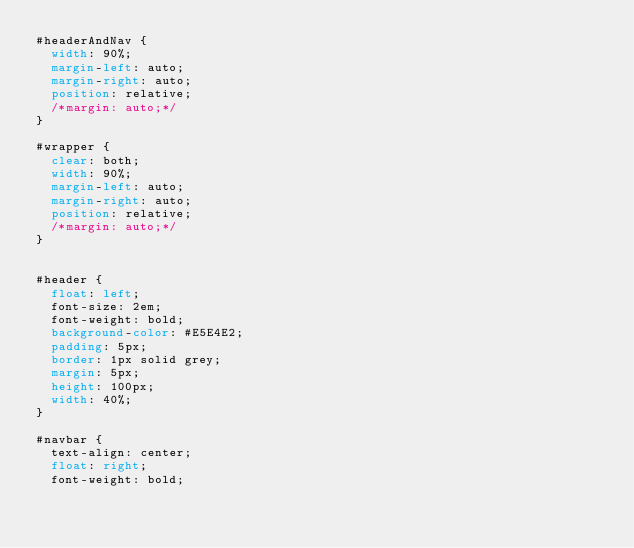<code> <loc_0><loc_0><loc_500><loc_500><_CSS_>#headerAndNav {
  width: 90%;
  margin-left: auto;
  margin-right: auto;
  position: relative;
  /*margin: auto;*/
}

#wrapper {
  clear: both;
  width: 90%;
  margin-left: auto;
  margin-right: auto;
  position: relative;
  /*margin: auto;*/
}


#header {
  float: left;
  font-size: 2em;
  font-weight: bold;
  background-color: #E5E4E2;
  padding: 5px;
  border: 1px solid grey;
  margin: 5px;
  height: 100px;
  width: 40%;
}

#navbar {
  text-align: center;
  float: right;
  font-weight: bold;</code> 